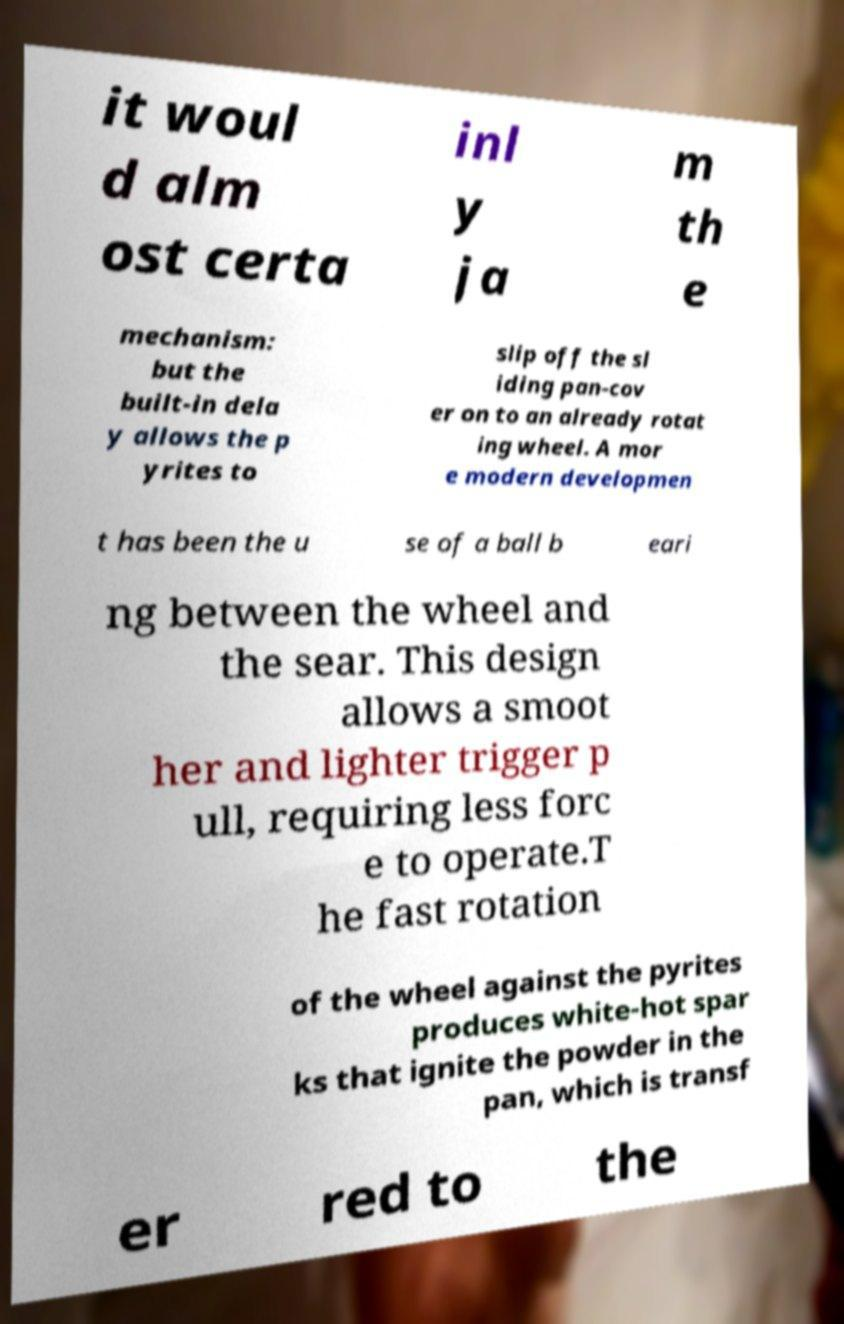For documentation purposes, I need the text within this image transcribed. Could you provide that? it woul d alm ost certa inl y ja m th e mechanism: but the built-in dela y allows the p yrites to slip off the sl iding pan-cov er on to an already rotat ing wheel. A mor e modern developmen t has been the u se of a ball b eari ng between the wheel and the sear. This design allows a smoot her and lighter trigger p ull, requiring less forc e to operate.T he fast rotation of the wheel against the pyrites produces white-hot spar ks that ignite the powder in the pan, which is transf er red to the 